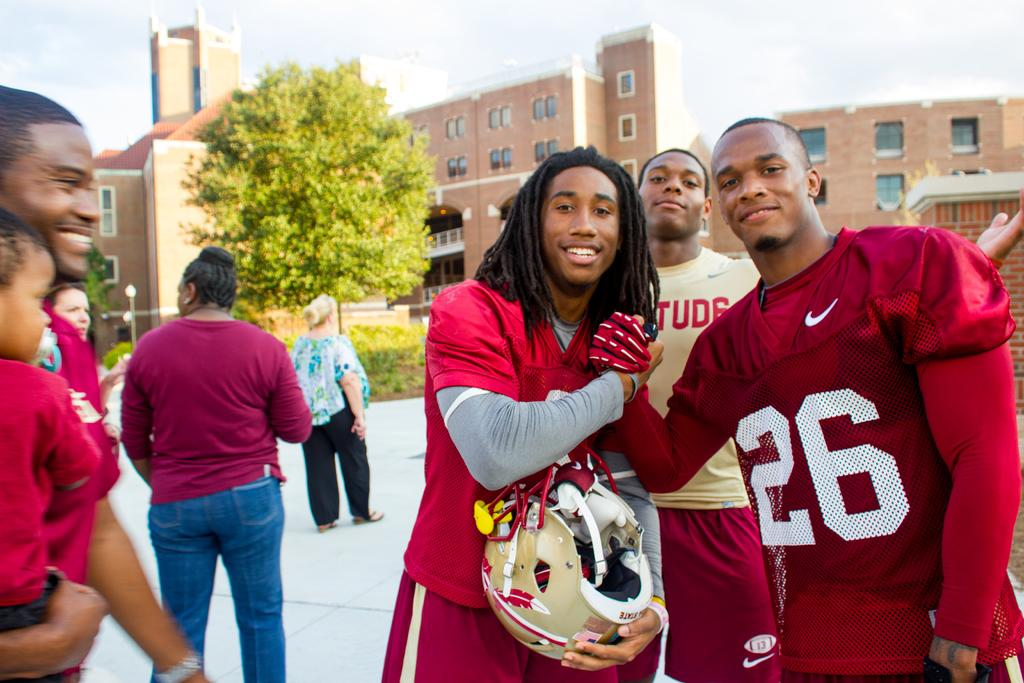<image>
Summarize the visual content of the image. Two football players, one with a number 26 uniform, clasp hands together 